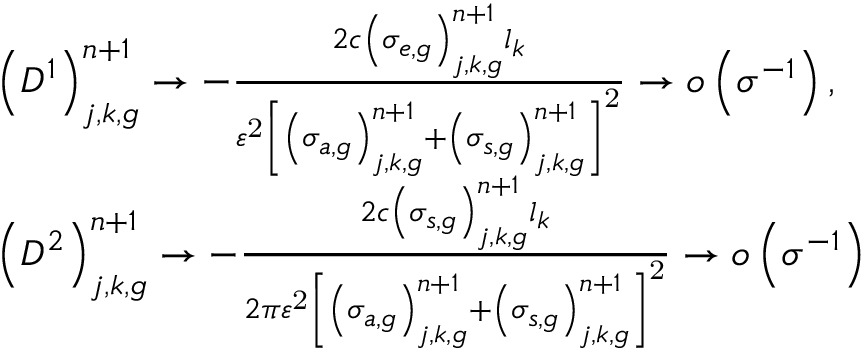<formula> <loc_0><loc_0><loc_500><loc_500>\begin{array} { l } { { \left ( D ^ { 1 } \right ) _ { j , k , g } ^ { n + 1 } \to - \frac { 2 c \left ( \sigma _ { e , g } \right ) _ { j , k , g } ^ { n + 1 } l _ { k } } { \varepsilon ^ { 2 } \left [ \left ( \sigma _ { a , g } \right ) _ { j , k , g } ^ { n + 1 } + \left ( \sigma _ { s , g } \right ) _ { j , k , g } ^ { n + 1 } \right ] ^ { 2 } } \to o \left ( \sigma ^ { - 1 } \right ) , } } \\ { { \left ( D ^ { 2 } \right ) _ { j , k , g } ^ { n + 1 } \to - \frac { 2 c \left ( \sigma _ { s , g } \right ) _ { j , k , g } ^ { n + 1 } l _ { k } } { 2 \pi \varepsilon ^ { 2 } \left [ \left ( \sigma _ { a , g } \right ) _ { j , k , g } ^ { n + 1 } + \left ( \sigma _ { s , g } \right ) _ { j , k , g } ^ { n + 1 } \right ] ^ { 2 } } \to o \left ( \sigma ^ { - 1 } \right ) } } \end{array}</formula> 